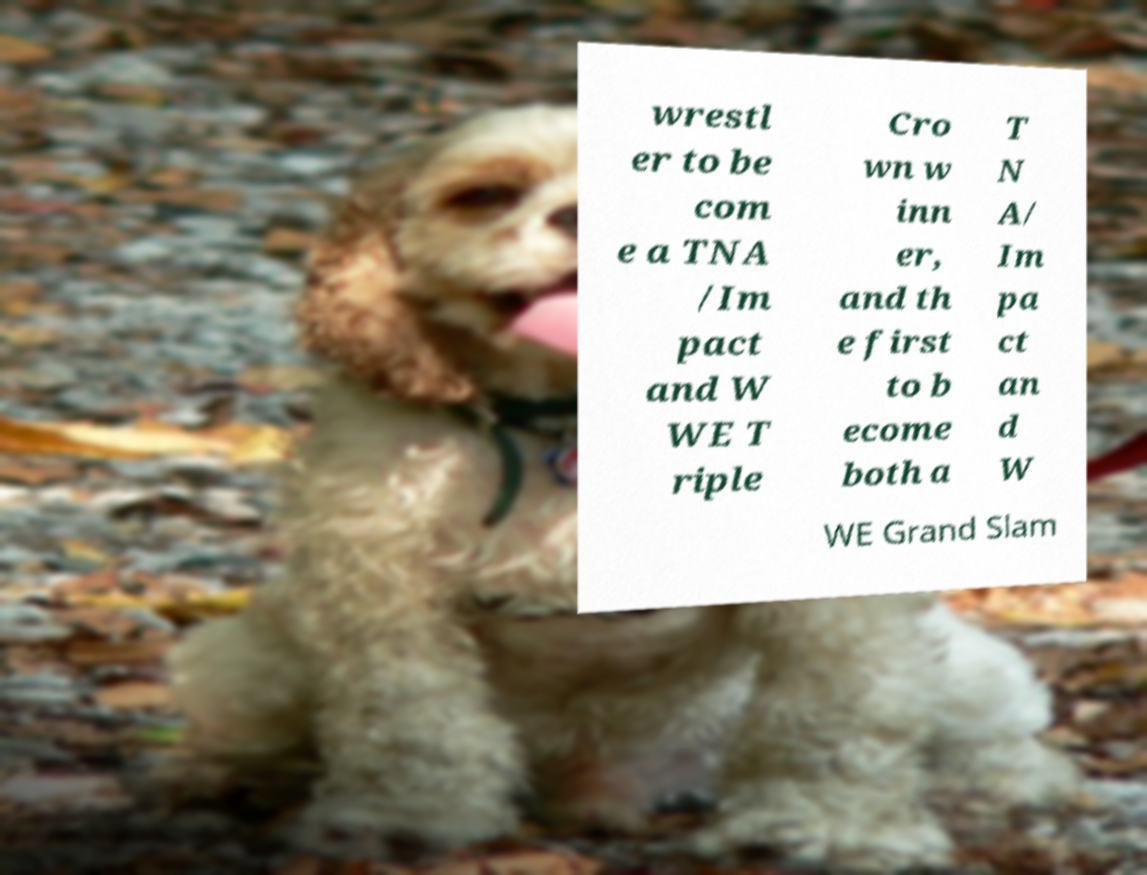What messages or text are displayed in this image? I need them in a readable, typed format. wrestl er to be com e a TNA /Im pact and W WE T riple Cro wn w inn er, and th e first to b ecome both a T N A/ Im pa ct an d W WE Grand Slam 